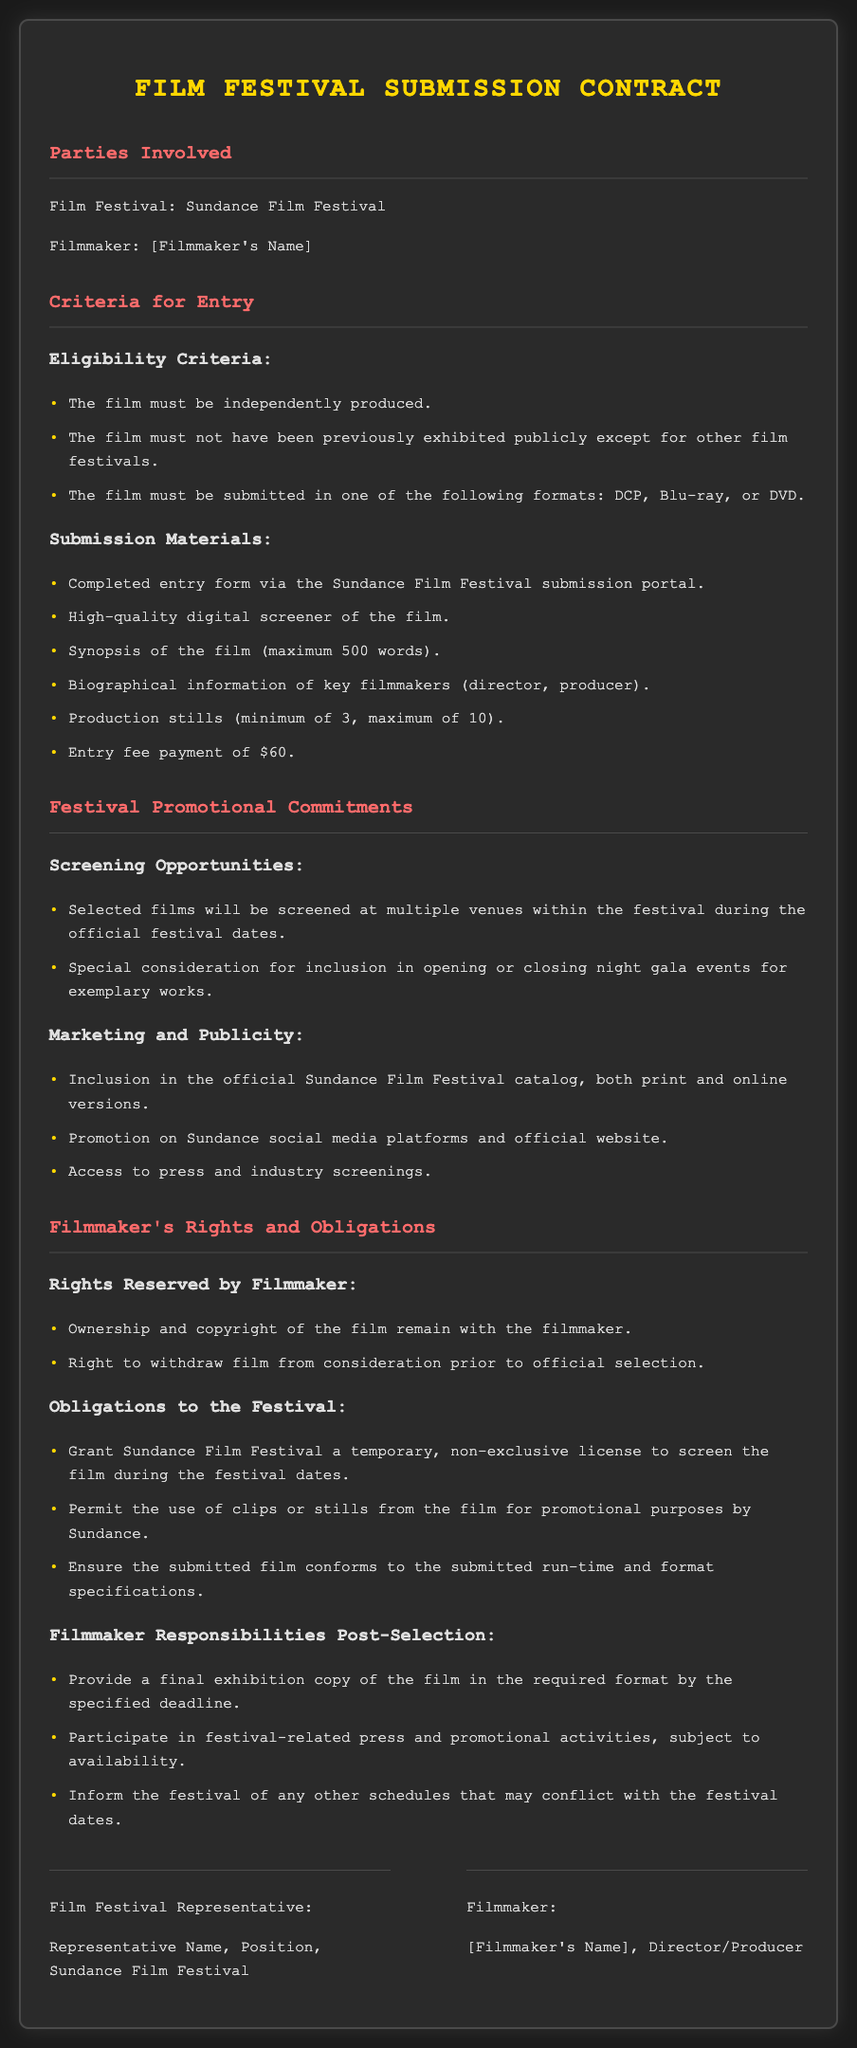What is the name of the festival? The name of the festival is stated in the document under "Parties Involved".
Answer: Sundance Film Festival What is the entry fee? The entry fee is mentioned in the section detailing submission materials.
Answer: $60 What is the maximum word count for the synopsis? The maximum word count for the synopsis is specified in the submission materials section.
Answer: 500 words What license is granted to Sundance by the filmmaker? The license granted is referred to in the obligations to the festival section.
Answer: Temporary, non-exclusive license How many production stills are required at minimum? The minimum number of production stills is outlined in the submission materials section.
Answer: 3 What must the filmmaker provide post-selection? The filmmaker's responsibilities post-selection are detailed, indicating what they must provide.
Answer: Final exhibition copy What rights remain with the filmmaker? The rights reserved by the filmmaker are listed in the rights section.
Answer: Ownership and copyright What additional promotional commitments are included by the festival? The festival's promotional commitments include marketing and publicity actions outlined in the document.
Answer: Promotion on Sundance social media platforms 